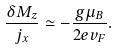<formula> <loc_0><loc_0><loc_500><loc_500>\frac { \delta M _ { z } } { j _ { x } } \simeq - \frac { g \mu _ { B } } { 2 e v _ { F } } .</formula> 